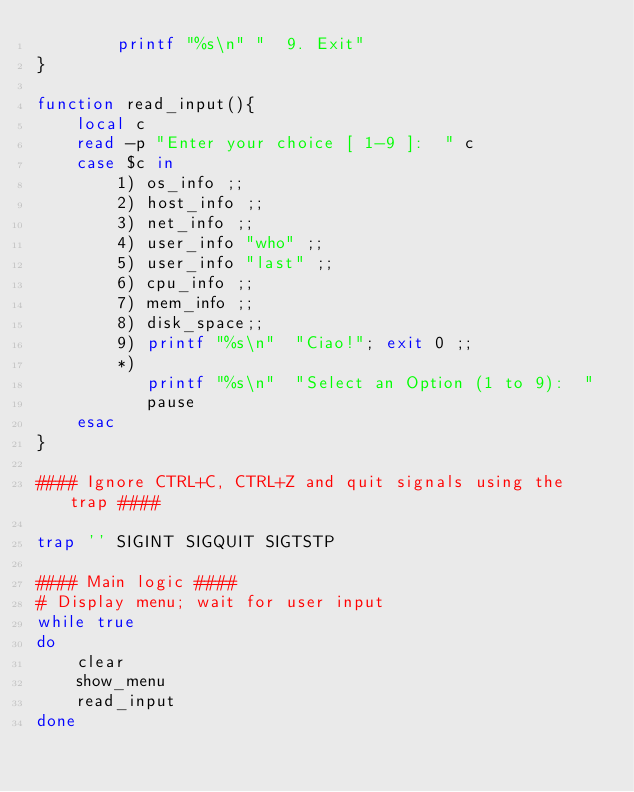<code> <loc_0><loc_0><loc_500><loc_500><_Bash_>        printf "%s\n" "  9. Exit" 
}

function read_input(){
    local c
    read -p "Enter your choice [ 1-9 ]:  " c
    case $c in
        1) os_info ;;
        2) host_info ;;
        3) net_info ;;
        4) user_info "who" ;;
        5) user_info "last" ;;
        6) cpu_info ;;
        7) mem_info ;;
        8) disk_space;;
        9) printf "%s\n"  "Ciao!"; exit 0 ;;
        *) 
           printf "%s\n"  "Select an Option (1 to 9):  "
           pause
    esac
}

#### Ignore CTRL+C, CTRL+Z and quit signals using the trap ####

trap '' SIGINT SIGQUIT SIGTSTP

#### Main logic ####
# Display menu; wait for user input 
while true 
do
    clear
    show_menu
    read_input
done
</code> 